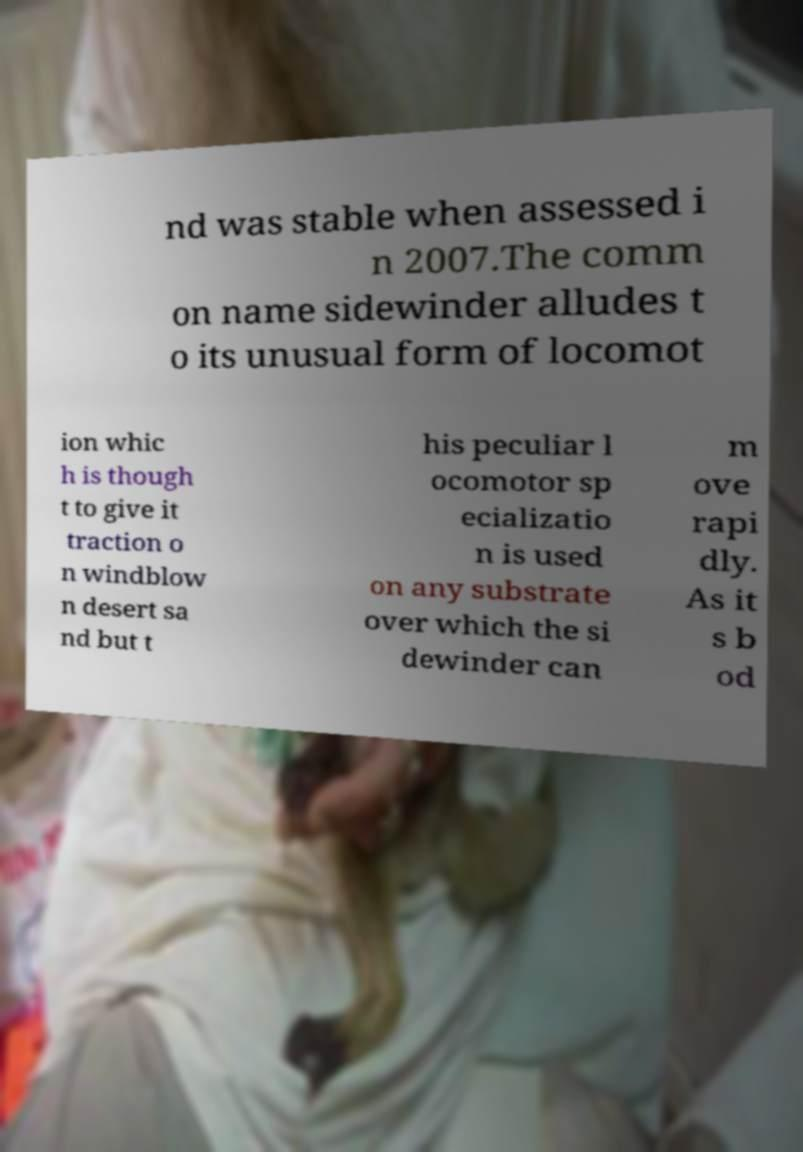I need the written content from this picture converted into text. Can you do that? nd was stable when assessed i n 2007.The comm on name sidewinder alludes t o its unusual form of locomot ion whic h is though t to give it traction o n windblow n desert sa nd but t his peculiar l ocomotor sp ecializatio n is used on any substrate over which the si dewinder can m ove rapi dly. As it s b od 